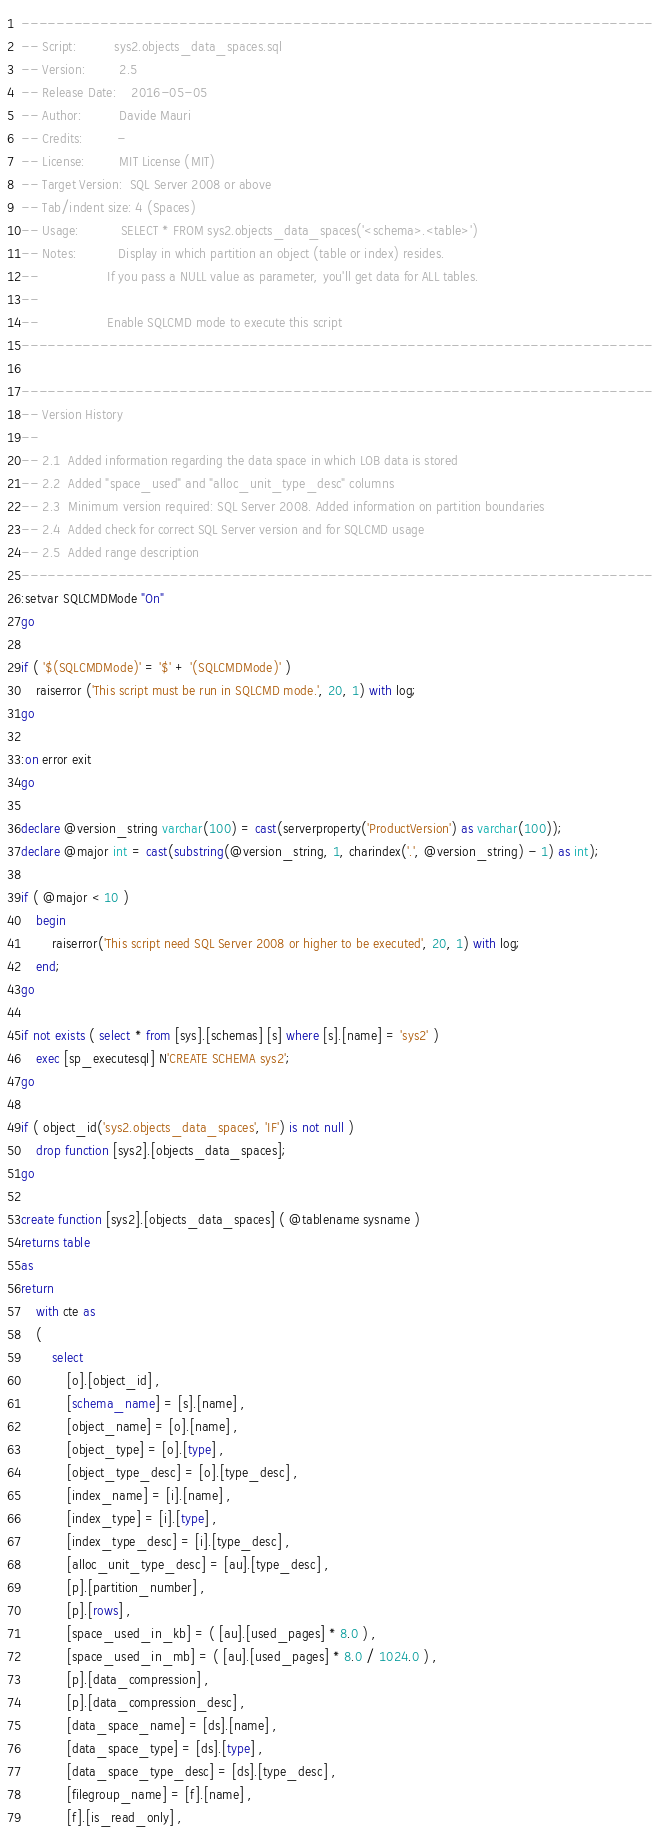Convert code to text. <code><loc_0><loc_0><loc_500><loc_500><_SQL_>------------------------------------------------------------------------
-- Script:          sys2.objects_data_spaces.sql
-- Version:         2.5
-- Release Date:    2016-05-05
-- Author:          Davide Mauri
-- Credits:         -
-- License:         MIT License (MIT)
-- Target Version:  SQL Server 2008 or above
-- Tab/indent size: 4 (Spaces)
-- Usage:           SELECT * FROM sys2.objects_data_spaces('<schema>.<table>')                  
-- Notes:           Display in which partition an object (table or index) resides.
--                  If you pass a NULL value as parameter, you'll get data for ALL tables.
--
-- 					Enable SQLCMD mode to execute this script
------------------------------------------------------------------------

------------------------------------------------------------------------
-- Version History
--
-- 2.1  Added information regarding the data space in which LOB data is stored
-- 2.2  Added "space_used" and "alloc_unit_type_desc" columns
-- 2.3  Minimum version required: SQL Server 2008. Added information on partition boundaries
-- 2.4	Added check for correct SQL Server version and for SQLCMD usage
-- 2.5	Added range description		
------------------------------------------------------------------------
:setvar SQLCMDMode "On"
go

if ( '$(SQLCMDMode)' = '$' + '(SQLCMDMode)' )
    raiserror ('This script must be run in SQLCMD mode.', 20, 1) with log;
go

:on error exit
go

declare @version_string varchar(100) = cast(serverproperty('ProductVersion') as varchar(100));
declare @major int = cast(substring(@version_string, 1, charindex('.', @version_string) - 1) as int);

if ( @major < 10 )
    begin
        raiserror('This script need SQL Server 2008 or higher to be executed', 20, 1) with log;
    end;
go

if not exists ( select * from [sys].[schemas] [s] where [s].[name] = 'sys2' )
    exec [sp_executesql] N'CREATE SCHEMA sys2';
go
    
if ( object_id('sys2.objects_data_spaces', 'IF') is not null )
    drop function [sys2].[objects_data_spaces];
go

create function [sys2].[objects_data_spaces] ( @tablename sysname )
returns table
as
return
	with cte as 
	(    
		select
			[o].[object_id] ,
            [schema_name] = [s].[name] ,
            [object_name] = [o].[name] ,
            [object_type] = [o].[type] ,
            [object_type_desc] = [o].[type_desc] ,
            [index_name] = [i].[name] ,
            [index_type] = [i].[type] ,
            [index_type_desc] = [i].[type_desc] ,
            [alloc_unit_type_desc] = [au].[type_desc] ,
            [p].[partition_number] ,
            [p].[rows] ,
            [space_used_in_kb] = ( [au].[used_pages] * 8.0 ) ,
            [space_used_in_mb] = ( [au].[used_pages] * 8.0 / 1024.0 ) ,
            [p].[data_compression] ,
            [p].[data_compression_desc] ,
            [data_space_name] = [ds].[name] ,
            [data_space_type] = [ds].[type] ,
            [data_space_type_desc] = [ds].[type_desc] ,
            [filegroup_name] = [f].[name] ,
            [f].[is_read_only] ,</code> 